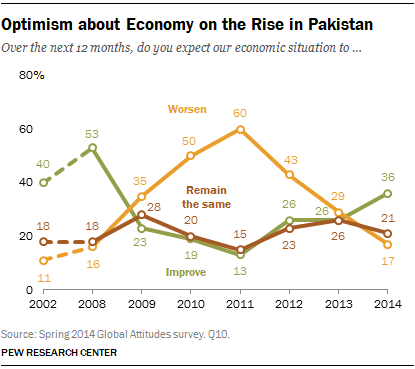Point out several critical features in this image. The ratio of the highest orange data point to the rightmost green data point is 1.6667, which can be expressed as a decimal. There are three colored lines. 